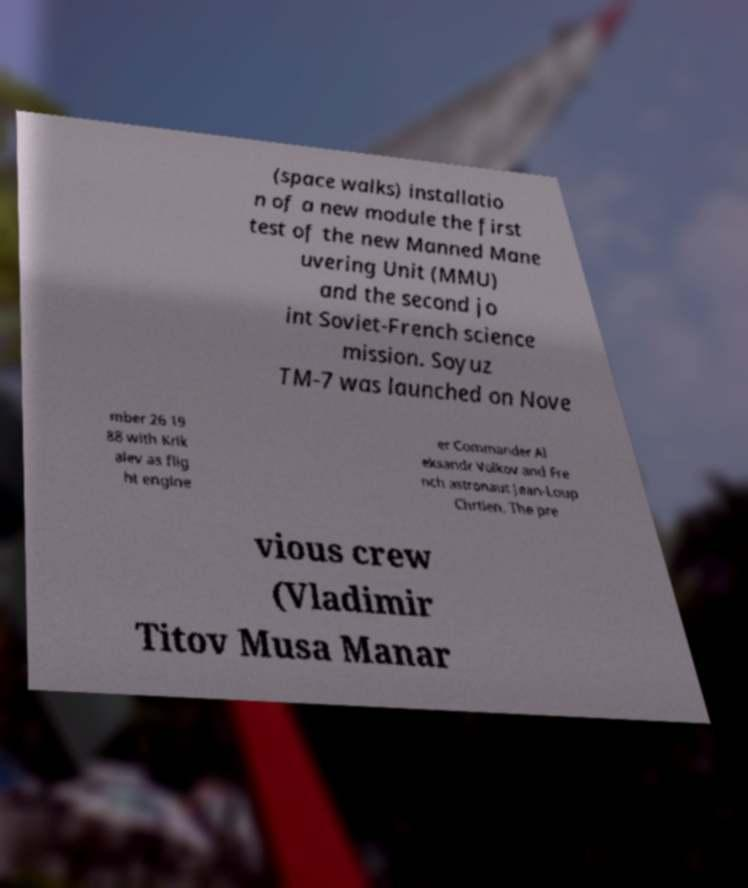For documentation purposes, I need the text within this image transcribed. Could you provide that? (space walks) installatio n of a new module the first test of the new Manned Mane uvering Unit (MMU) and the second jo int Soviet-French science mission. Soyuz TM-7 was launched on Nove mber 26 19 88 with Krik alev as flig ht engine er Commander Al eksandr Volkov and Fre nch astronaut Jean-Loup Chrtien. The pre vious crew (Vladimir Titov Musa Manar 